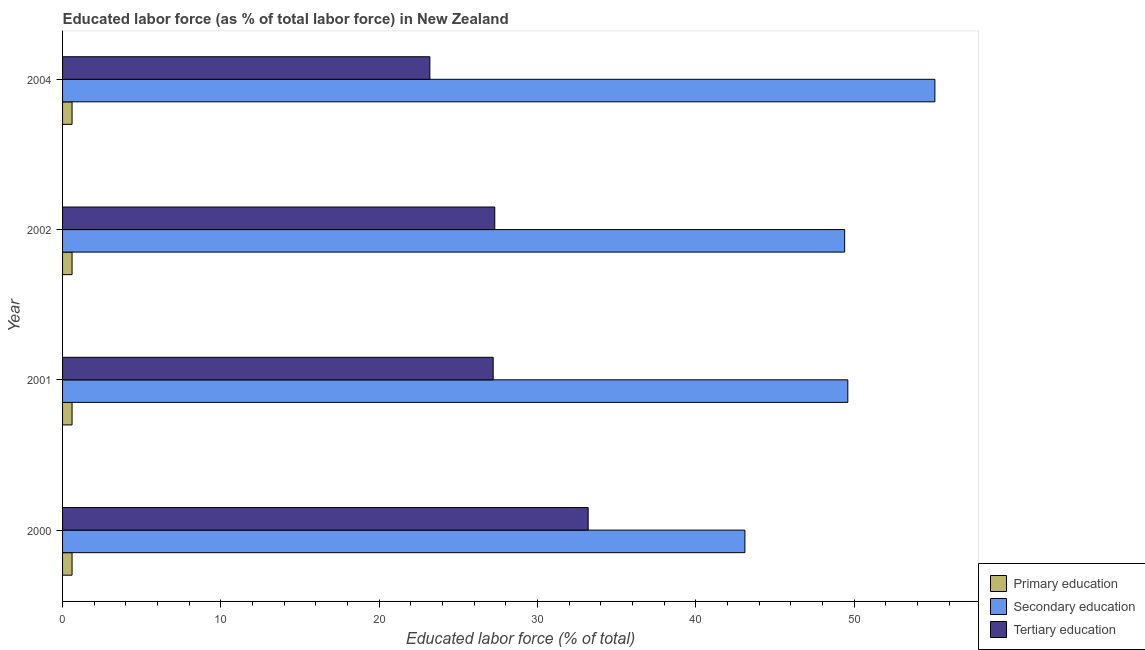How many groups of bars are there?
Offer a terse response. 4. Are the number of bars on each tick of the Y-axis equal?
Ensure brevity in your answer.  Yes. How many bars are there on the 1st tick from the bottom?
Your answer should be compact. 3. In how many cases, is the number of bars for a given year not equal to the number of legend labels?
Provide a succinct answer. 0. What is the percentage of labor force who received primary education in 2002?
Provide a short and direct response. 0.6. Across all years, what is the maximum percentage of labor force who received secondary education?
Ensure brevity in your answer.  55.1. Across all years, what is the minimum percentage of labor force who received secondary education?
Provide a succinct answer. 43.1. What is the total percentage of labor force who received primary education in the graph?
Ensure brevity in your answer.  2.4. What is the difference between the percentage of labor force who received secondary education in 2004 and the percentage of labor force who received primary education in 2000?
Ensure brevity in your answer.  54.5. In the year 2001, what is the difference between the percentage of labor force who received tertiary education and percentage of labor force who received primary education?
Offer a terse response. 26.6. What is the ratio of the percentage of labor force who received secondary education in 2002 to that in 2004?
Your answer should be very brief. 0.9. Is the difference between the percentage of labor force who received tertiary education in 2000 and 2001 greater than the difference between the percentage of labor force who received secondary education in 2000 and 2001?
Your answer should be compact. Yes. In how many years, is the percentage of labor force who received secondary education greater than the average percentage of labor force who received secondary education taken over all years?
Provide a short and direct response. 3. Is the sum of the percentage of labor force who received tertiary education in 2000 and 2004 greater than the maximum percentage of labor force who received primary education across all years?
Your answer should be very brief. Yes. What does the 2nd bar from the top in 2000 represents?
Your answer should be very brief. Secondary education. What does the 2nd bar from the bottom in 2001 represents?
Keep it short and to the point. Secondary education. Is it the case that in every year, the sum of the percentage of labor force who received primary education and percentage of labor force who received secondary education is greater than the percentage of labor force who received tertiary education?
Offer a very short reply. Yes. Are the values on the major ticks of X-axis written in scientific E-notation?
Keep it short and to the point. No. Does the graph contain any zero values?
Make the answer very short. No. How many legend labels are there?
Provide a succinct answer. 3. How are the legend labels stacked?
Provide a short and direct response. Vertical. What is the title of the graph?
Provide a short and direct response. Educated labor force (as % of total labor force) in New Zealand. What is the label or title of the X-axis?
Make the answer very short. Educated labor force (% of total). What is the Educated labor force (% of total) in Primary education in 2000?
Provide a succinct answer. 0.6. What is the Educated labor force (% of total) in Secondary education in 2000?
Your answer should be compact. 43.1. What is the Educated labor force (% of total) in Tertiary education in 2000?
Ensure brevity in your answer.  33.2. What is the Educated labor force (% of total) of Primary education in 2001?
Provide a short and direct response. 0.6. What is the Educated labor force (% of total) of Secondary education in 2001?
Your answer should be very brief. 49.6. What is the Educated labor force (% of total) in Tertiary education in 2001?
Offer a very short reply. 27.2. What is the Educated labor force (% of total) of Primary education in 2002?
Give a very brief answer. 0.6. What is the Educated labor force (% of total) in Secondary education in 2002?
Give a very brief answer. 49.4. What is the Educated labor force (% of total) in Tertiary education in 2002?
Keep it short and to the point. 27.3. What is the Educated labor force (% of total) in Primary education in 2004?
Ensure brevity in your answer.  0.6. What is the Educated labor force (% of total) in Secondary education in 2004?
Ensure brevity in your answer.  55.1. What is the Educated labor force (% of total) in Tertiary education in 2004?
Make the answer very short. 23.2. Across all years, what is the maximum Educated labor force (% of total) of Primary education?
Your answer should be compact. 0.6. Across all years, what is the maximum Educated labor force (% of total) of Secondary education?
Provide a succinct answer. 55.1. Across all years, what is the maximum Educated labor force (% of total) of Tertiary education?
Offer a terse response. 33.2. Across all years, what is the minimum Educated labor force (% of total) of Primary education?
Offer a terse response. 0.6. Across all years, what is the minimum Educated labor force (% of total) in Secondary education?
Provide a succinct answer. 43.1. Across all years, what is the minimum Educated labor force (% of total) in Tertiary education?
Provide a succinct answer. 23.2. What is the total Educated labor force (% of total) in Primary education in the graph?
Provide a short and direct response. 2.4. What is the total Educated labor force (% of total) of Secondary education in the graph?
Offer a very short reply. 197.2. What is the total Educated labor force (% of total) in Tertiary education in the graph?
Provide a succinct answer. 110.9. What is the difference between the Educated labor force (% of total) in Secondary education in 2000 and that in 2001?
Ensure brevity in your answer.  -6.5. What is the difference between the Educated labor force (% of total) of Tertiary education in 2000 and that in 2001?
Your response must be concise. 6. What is the difference between the Educated labor force (% of total) of Secondary education in 2000 and that in 2002?
Keep it short and to the point. -6.3. What is the difference between the Educated labor force (% of total) in Secondary education in 2000 and that in 2004?
Provide a succinct answer. -12. What is the difference between the Educated labor force (% of total) in Primary education in 2001 and that in 2002?
Your response must be concise. 0. What is the difference between the Educated labor force (% of total) of Tertiary education in 2001 and that in 2002?
Your response must be concise. -0.1. What is the difference between the Educated labor force (% of total) in Primary education in 2002 and that in 2004?
Provide a succinct answer. 0. What is the difference between the Educated labor force (% of total) in Tertiary education in 2002 and that in 2004?
Your response must be concise. 4.1. What is the difference between the Educated labor force (% of total) of Primary education in 2000 and the Educated labor force (% of total) of Secondary education in 2001?
Your answer should be very brief. -49. What is the difference between the Educated labor force (% of total) in Primary education in 2000 and the Educated labor force (% of total) in Tertiary education in 2001?
Your response must be concise. -26.6. What is the difference between the Educated labor force (% of total) of Secondary education in 2000 and the Educated labor force (% of total) of Tertiary education in 2001?
Provide a short and direct response. 15.9. What is the difference between the Educated labor force (% of total) in Primary education in 2000 and the Educated labor force (% of total) in Secondary education in 2002?
Keep it short and to the point. -48.8. What is the difference between the Educated labor force (% of total) in Primary education in 2000 and the Educated labor force (% of total) in Tertiary education in 2002?
Keep it short and to the point. -26.7. What is the difference between the Educated labor force (% of total) of Primary education in 2000 and the Educated labor force (% of total) of Secondary education in 2004?
Ensure brevity in your answer.  -54.5. What is the difference between the Educated labor force (% of total) in Primary education in 2000 and the Educated labor force (% of total) in Tertiary education in 2004?
Provide a short and direct response. -22.6. What is the difference between the Educated labor force (% of total) in Primary education in 2001 and the Educated labor force (% of total) in Secondary education in 2002?
Keep it short and to the point. -48.8. What is the difference between the Educated labor force (% of total) of Primary education in 2001 and the Educated labor force (% of total) of Tertiary education in 2002?
Provide a succinct answer. -26.7. What is the difference between the Educated labor force (% of total) of Secondary education in 2001 and the Educated labor force (% of total) of Tertiary education in 2002?
Offer a terse response. 22.3. What is the difference between the Educated labor force (% of total) of Primary education in 2001 and the Educated labor force (% of total) of Secondary education in 2004?
Your response must be concise. -54.5. What is the difference between the Educated labor force (% of total) of Primary education in 2001 and the Educated labor force (% of total) of Tertiary education in 2004?
Give a very brief answer. -22.6. What is the difference between the Educated labor force (% of total) in Secondary education in 2001 and the Educated labor force (% of total) in Tertiary education in 2004?
Your answer should be compact. 26.4. What is the difference between the Educated labor force (% of total) in Primary education in 2002 and the Educated labor force (% of total) in Secondary education in 2004?
Provide a short and direct response. -54.5. What is the difference between the Educated labor force (% of total) in Primary education in 2002 and the Educated labor force (% of total) in Tertiary education in 2004?
Provide a succinct answer. -22.6. What is the difference between the Educated labor force (% of total) of Secondary education in 2002 and the Educated labor force (% of total) of Tertiary education in 2004?
Keep it short and to the point. 26.2. What is the average Educated labor force (% of total) of Primary education per year?
Your answer should be very brief. 0.6. What is the average Educated labor force (% of total) of Secondary education per year?
Give a very brief answer. 49.3. What is the average Educated labor force (% of total) of Tertiary education per year?
Your response must be concise. 27.73. In the year 2000, what is the difference between the Educated labor force (% of total) in Primary education and Educated labor force (% of total) in Secondary education?
Your answer should be compact. -42.5. In the year 2000, what is the difference between the Educated labor force (% of total) of Primary education and Educated labor force (% of total) of Tertiary education?
Your response must be concise. -32.6. In the year 2001, what is the difference between the Educated labor force (% of total) in Primary education and Educated labor force (% of total) in Secondary education?
Offer a very short reply. -49. In the year 2001, what is the difference between the Educated labor force (% of total) of Primary education and Educated labor force (% of total) of Tertiary education?
Provide a short and direct response. -26.6. In the year 2001, what is the difference between the Educated labor force (% of total) of Secondary education and Educated labor force (% of total) of Tertiary education?
Your answer should be compact. 22.4. In the year 2002, what is the difference between the Educated labor force (% of total) of Primary education and Educated labor force (% of total) of Secondary education?
Make the answer very short. -48.8. In the year 2002, what is the difference between the Educated labor force (% of total) of Primary education and Educated labor force (% of total) of Tertiary education?
Your answer should be compact. -26.7. In the year 2002, what is the difference between the Educated labor force (% of total) of Secondary education and Educated labor force (% of total) of Tertiary education?
Provide a succinct answer. 22.1. In the year 2004, what is the difference between the Educated labor force (% of total) in Primary education and Educated labor force (% of total) in Secondary education?
Keep it short and to the point. -54.5. In the year 2004, what is the difference between the Educated labor force (% of total) in Primary education and Educated labor force (% of total) in Tertiary education?
Give a very brief answer. -22.6. In the year 2004, what is the difference between the Educated labor force (% of total) in Secondary education and Educated labor force (% of total) in Tertiary education?
Give a very brief answer. 31.9. What is the ratio of the Educated labor force (% of total) of Secondary education in 2000 to that in 2001?
Your answer should be very brief. 0.87. What is the ratio of the Educated labor force (% of total) in Tertiary education in 2000 to that in 2001?
Offer a very short reply. 1.22. What is the ratio of the Educated labor force (% of total) in Secondary education in 2000 to that in 2002?
Provide a short and direct response. 0.87. What is the ratio of the Educated labor force (% of total) in Tertiary education in 2000 to that in 2002?
Give a very brief answer. 1.22. What is the ratio of the Educated labor force (% of total) in Secondary education in 2000 to that in 2004?
Your response must be concise. 0.78. What is the ratio of the Educated labor force (% of total) in Tertiary education in 2000 to that in 2004?
Offer a terse response. 1.43. What is the ratio of the Educated labor force (% of total) of Secondary education in 2001 to that in 2002?
Offer a very short reply. 1. What is the ratio of the Educated labor force (% of total) in Tertiary education in 2001 to that in 2002?
Offer a very short reply. 1. What is the ratio of the Educated labor force (% of total) of Primary education in 2001 to that in 2004?
Make the answer very short. 1. What is the ratio of the Educated labor force (% of total) in Secondary education in 2001 to that in 2004?
Make the answer very short. 0.9. What is the ratio of the Educated labor force (% of total) in Tertiary education in 2001 to that in 2004?
Provide a short and direct response. 1.17. What is the ratio of the Educated labor force (% of total) of Secondary education in 2002 to that in 2004?
Your answer should be compact. 0.9. What is the ratio of the Educated labor force (% of total) of Tertiary education in 2002 to that in 2004?
Provide a short and direct response. 1.18. What is the difference between the highest and the lowest Educated labor force (% of total) in Secondary education?
Your answer should be very brief. 12. What is the difference between the highest and the lowest Educated labor force (% of total) of Tertiary education?
Give a very brief answer. 10. 